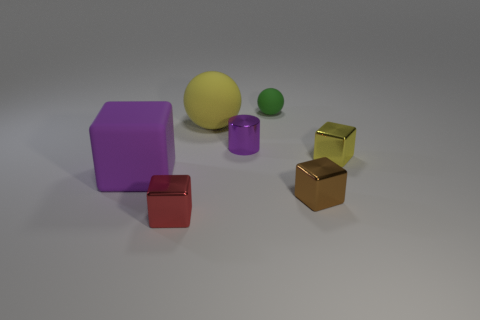Do the big thing that is on the left side of the large matte ball and the green thing have the same material?
Make the answer very short. Yes. What number of things are on the right side of the yellow matte thing and in front of the big yellow thing?
Make the answer very short. 3. What number of other things have the same material as the small green thing?
Offer a very short reply. 2. What is the color of the other large ball that is the same material as the green ball?
Ensure brevity in your answer.  Yellow. Are there fewer tiny purple objects than red rubber cylinders?
Make the answer very short. No. What material is the tiny yellow block that is in front of the tiny purple cylinder behind the small metal cube that is behind the brown block?
Your response must be concise. Metal. What is the small purple cylinder made of?
Your answer should be very brief. Metal. There is a big object that is behind the large matte cube; is its color the same as the metal cube to the left of the green thing?
Ensure brevity in your answer.  No. Are there more small metal cylinders than large purple rubber cylinders?
Ensure brevity in your answer.  Yes. How many small matte things are the same color as the tiny cylinder?
Provide a short and direct response. 0. 